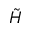<formula> <loc_0><loc_0><loc_500><loc_500>\tilde { H }</formula> 